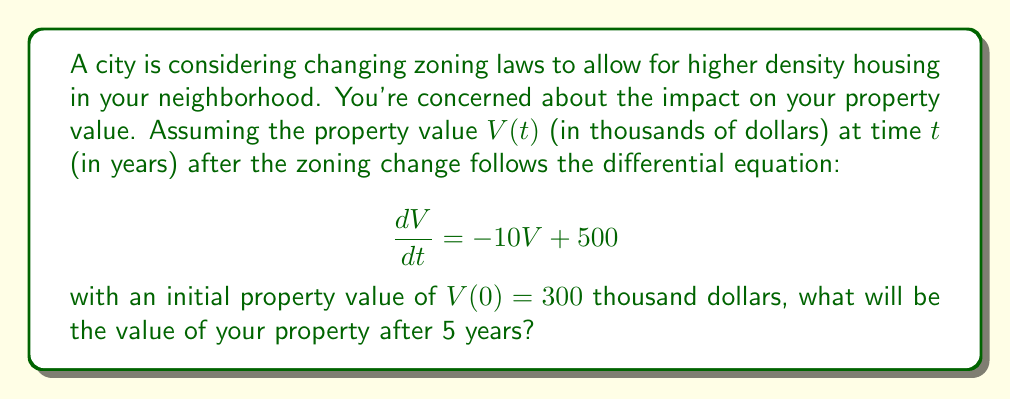Can you solve this math problem? To solve this problem, we need to follow these steps:

1) We have a first-order linear differential equation:

   $$\frac{dV}{dt} = -10V + 500$$

2) This is in the form $\frac{dV}{dt} + PV = Q$, where $P = 10$ and $Q = 500$.

3) The general solution for this type of equation is:

   $$V(t) = e^{-\int P dt} (\int Q e^{\int P dt} dt + C)$$

4) Solving the integrals:

   $\int P dt = \int 10 dt = 10t$
   $e^{\int P dt} = e^{10t}$

5) Substituting into the general solution:

   $$V(t) = e^{-10t} (\int 500 e^{10t} dt + C)$$

6) Solving the remaining integral:

   $$V(t) = e^{-10t} (\frac{500}{10} e^{10t} + C) = 50 + Ce^{-10t}$$

7) Using the initial condition $V(0) = 300$:

   $300 = 50 + C$
   $C = 250$

8) Therefore, the particular solution is:

   $$V(t) = 50 + 250e^{-10t}$$

9) To find the value after 5 years, we substitute $t = 5$:

   $$V(5) = 50 + 250e^{-50} \approx 50.000000004$$
Answer: $50,000 